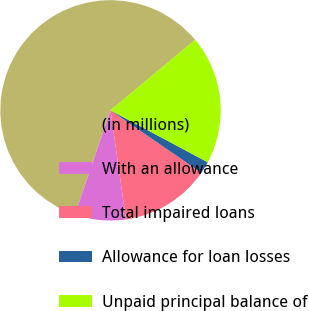Convert chart to OTSL. <chart><loc_0><loc_0><loc_500><loc_500><pie_chart><fcel>(in millions)<fcel>With an allowance<fcel>Total impaired loans<fcel>Allowance for loan losses<fcel>Unpaid principal balance of<nl><fcel>58.71%<fcel>7.48%<fcel>13.17%<fcel>1.78%<fcel>18.86%<nl></chart> 